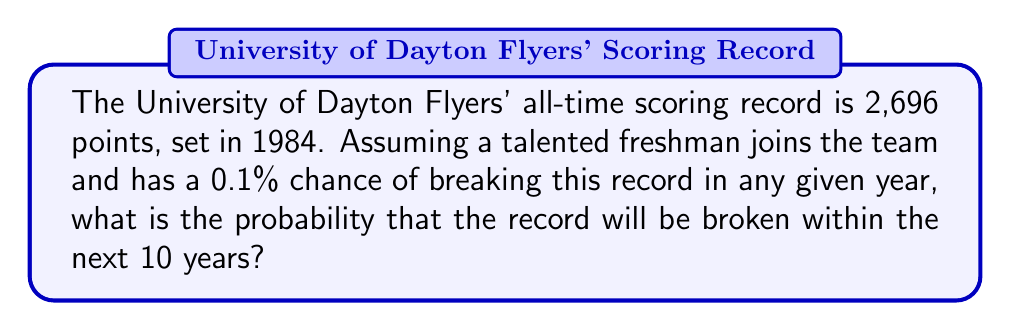Could you help me with this problem? Let's approach this step-by-step:

1) First, we need to calculate the probability that the record is not broken in a single year. 
   If the probability of breaking the record is 0.001 (0.1%), then:
   $P(\text{not broken in one year}) = 1 - 0.001 = 0.999$

2) Now, we want to find the probability that the record is not broken for 10 consecutive years. 
   Assuming independence between years, this is:
   $P(\text{not broken in 10 years}) = (0.999)^{10}$

3) We can calculate this:
   $$(0.999)^{10} \approx 0.9900$

4) The probability we're looking for is the opposite of this - the probability that the record is broken within 10 years. 
   This is:
   $$P(\text{broken within 10 years}) = 1 - P(\text{not broken in 10 years})$$
   $$= 1 - 0.9900 = 0.0100$$

5) Converting to a percentage:
   $0.0100 \times 100\% = 1\%$
Answer: 1% 